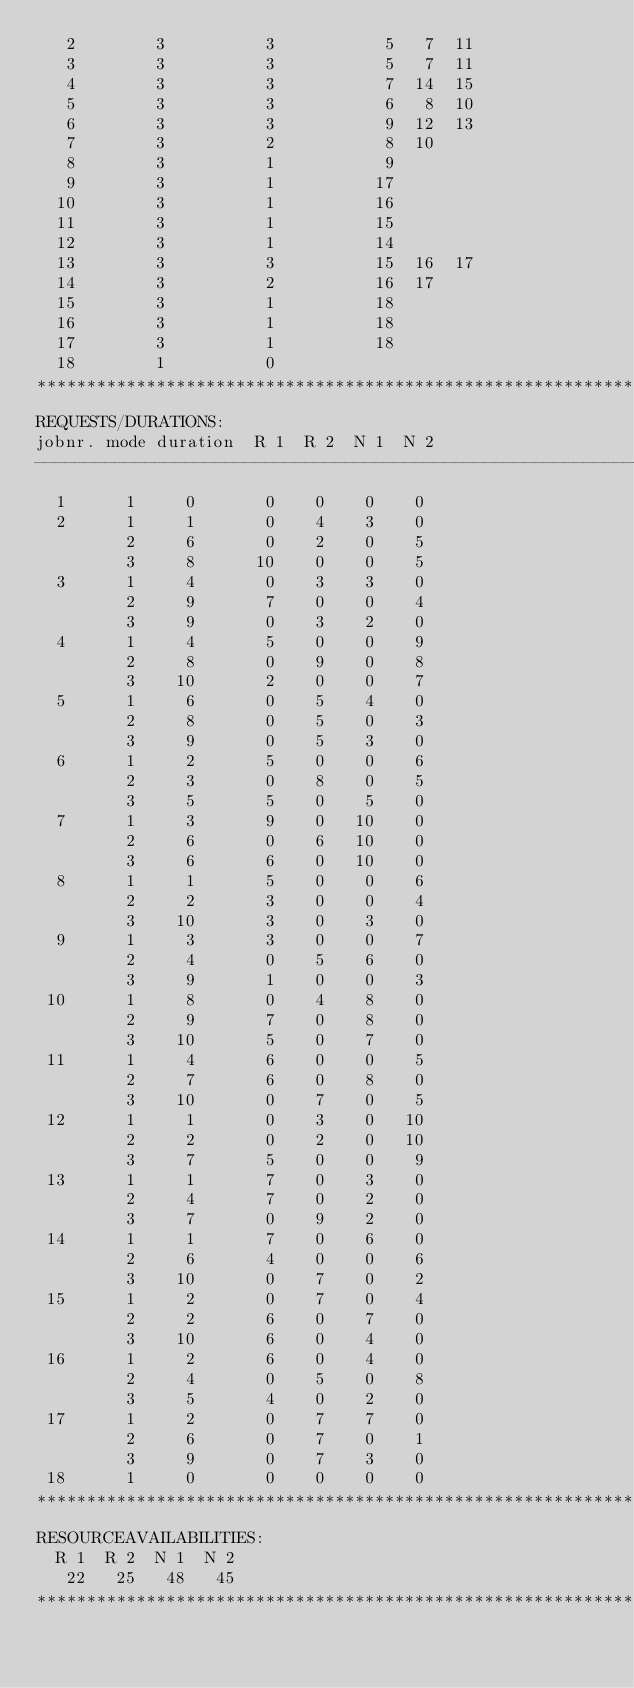<code> <loc_0><loc_0><loc_500><loc_500><_ObjectiveC_>   2        3          3           5   7  11
   3        3          3           5   7  11
   4        3          3           7  14  15
   5        3          3           6   8  10
   6        3          3           9  12  13
   7        3          2           8  10
   8        3          1           9
   9        3          1          17
  10        3          1          16
  11        3          1          15
  12        3          1          14
  13        3          3          15  16  17
  14        3          2          16  17
  15        3          1          18
  16        3          1          18
  17        3          1          18
  18        1          0        
************************************************************************
REQUESTS/DURATIONS:
jobnr. mode duration  R 1  R 2  N 1  N 2
------------------------------------------------------------------------
  1      1     0       0    0    0    0
  2      1     1       0    4    3    0
         2     6       0    2    0    5
         3     8      10    0    0    5
  3      1     4       0    3    3    0
         2     9       7    0    0    4
         3     9       0    3    2    0
  4      1     4       5    0    0    9
         2     8       0    9    0    8
         3    10       2    0    0    7
  5      1     6       0    5    4    0
         2     8       0    5    0    3
         3     9       0    5    3    0
  6      1     2       5    0    0    6
         2     3       0    8    0    5
         3     5       5    0    5    0
  7      1     3       9    0   10    0
         2     6       0    6   10    0
         3     6       6    0   10    0
  8      1     1       5    0    0    6
         2     2       3    0    0    4
         3    10       3    0    3    0
  9      1     3       3    0    0    7
         2     4       0    5    6    0
         3     9       1    0    0    3
 10      1     8       0    4    8    0
         2     9       7    0    8    0
         3    10       5    0    7    0
 11      1     4       6    0    0    5
         2     7       6    0    8    0
         3    10       0    7    0    5
 12      1     1       0    3    0   10
         2     2       0    2    0   10
         3     7       5    0    0    9
 13      1     1       7    0    3    0
         2     4       7    0    2    0
         3     7       0    9    2    0
 14      1     1       7    0    6    0
         2     6       4    0    0    6
         3    10       0    7    0    2
 15      1     2       0    7    0    4
         2     2       6    0    7    0
         3    10       6    0    4    0
 16      1     2       6    0    4    0
         2     4       0    5    0    8
         3     5       4    0    2    0
 17      1     2       0    7    7    0
         2     6       0    7    0    1
         3     9       0    7    3    0
 18      1     0       0    0    0    0
************************************************************************
RESOURCEAVAILABILITIES:
  R 1  R 2  N 1  N 2
   22   25   48   45
************************************************************************
</code> 